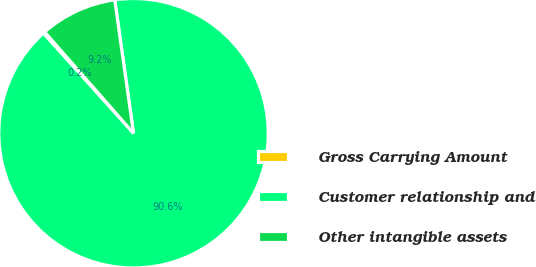<chart> <loc_0><loc_0><loc_500><loc_500><pie_chart><fcel>Gross Carrying Amount<fcel>Customer relationship and<fcel>Other intangible assets<nl><fcel>0.2%<fcel>90.56%<fcel>9.24%<nl></chart> 